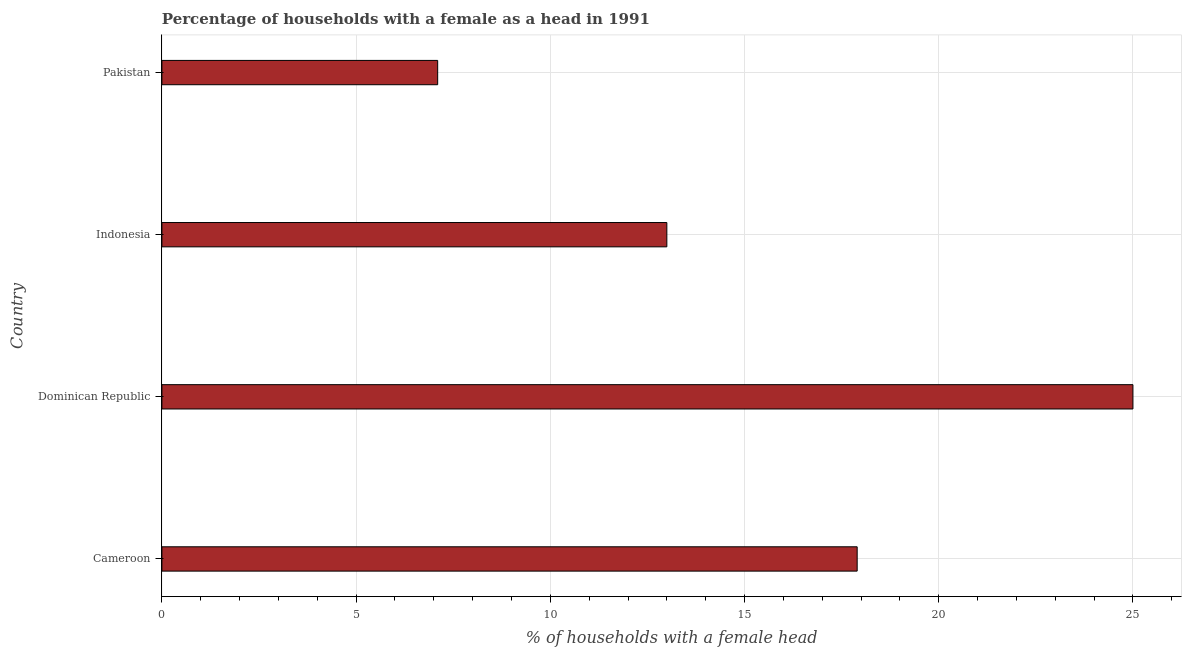What is the title of the graph?
Your answer should be compact. Percentage of households with a female as a head in 1991. What is the label or title of the X-axis?
Make the answer very short. % of households with a female head. In which country was the number of female supervised households maximum?
Provide a short and direct response. Dominican Republic. In which country was the number of female supervised households minimum?
Your response must be concise. Pakistan. What is the sum of the number of female supervised households?
Make the answer very short. 63. What is the difference between the number of female supervised households in Cameroon and Pakistan?
Make the answer very short. 10.8. What is the average number of female supervised households per country?
Provide a short and direct response. 15.75. What is the median number of female supervised households?
Your response must be concise. 15.45. What is the ratio of the number of female supervised households in Cameroon to that in Pakistan?
Offer a terse response. 2.52. Is the difference between the number of female supervised households in Cameroon and Dominican Republic greater than the difference between any two countries?
Offer a terse response. No. What is the difference between the highest and the second highest number of female supervised households?
Ensure brevity in your answer.  7.1. In how many countries, is the number of female supervised households greater than the average number of female supervised households taken over all countries?
Give a very brief answer. 2. How many bars are there?
Keep it short and to the point. 4. Are all the bars in the graph horizontal?
Ensure brevity in your answer.  Yes. What is the difference between two consecutive major ticks on the X-axis?
Provide a succinct answer. 5. What is the % of households with a female head of Cameroon?
Your answer should be compact. 17.9. What is the % of households with a female head in Dominican Republic?
Give a very brief answer. 25. What is the difference between the % of households with a female head in Cameroon and Pakistan?
Give a very brief answer. 10.8. What is the difference between the % of households with a female head in Dominican Republic and Indonesia?
Make the answer very short. 12. What is the difference between the % of households with a female head in Dominican Republic and Pakistan?
Make the answer very short. 17.9. What is the difference between the % of households with a female head in Indonesia and Pakistan?
Keep it short and to the point. 5.9. What is the ratio of the % of households with a female head in Cameroon to that in Dominican Republic?
Your answer should be compact. 0.72. What is the ratio of the % of households with a female head in Cameroon to that in Indonesia?
Offer a terse response. 1.38. What is the ratio of the % of households with a female head in Cameroon to that in Pakistan?
Offer a terse response. 2.52. What is the ratio of the % of households with a female head in Dominican Republic to that in Indonesia?
Make the answer very short. 1.92. What is the ratio of the % of households with a female head in Dominican Republic to that in Pakistan?
Give a very brief answer. 3.52. What is the ratio of the % of households with a female head in Indonesia to that in Pakistan?
Provide a succinct answer. 1.83. 